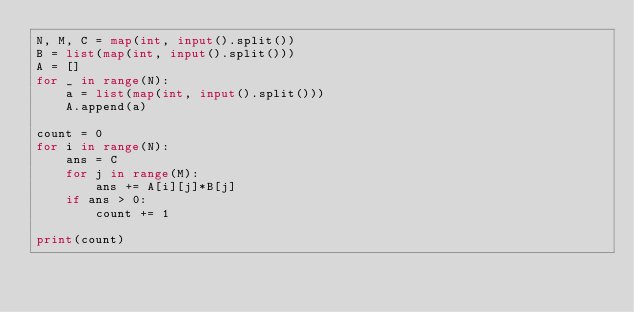Convert code to text. <code><loc_0><loc_0><loc_500><loc_500><_Python_>N, M, C = map(int, input().split())
B = list(map(int, input().split()))
A = []
for _ in range(N):
    a = list(map(int, input().split()))
    A.append(a)
    
count = 0
for i in range(N):
    ans = C
    for j in range(M):
        ans += A[i][j]*B[j]
    if ans > 0:
        count += 1
        
print(count)</code> 